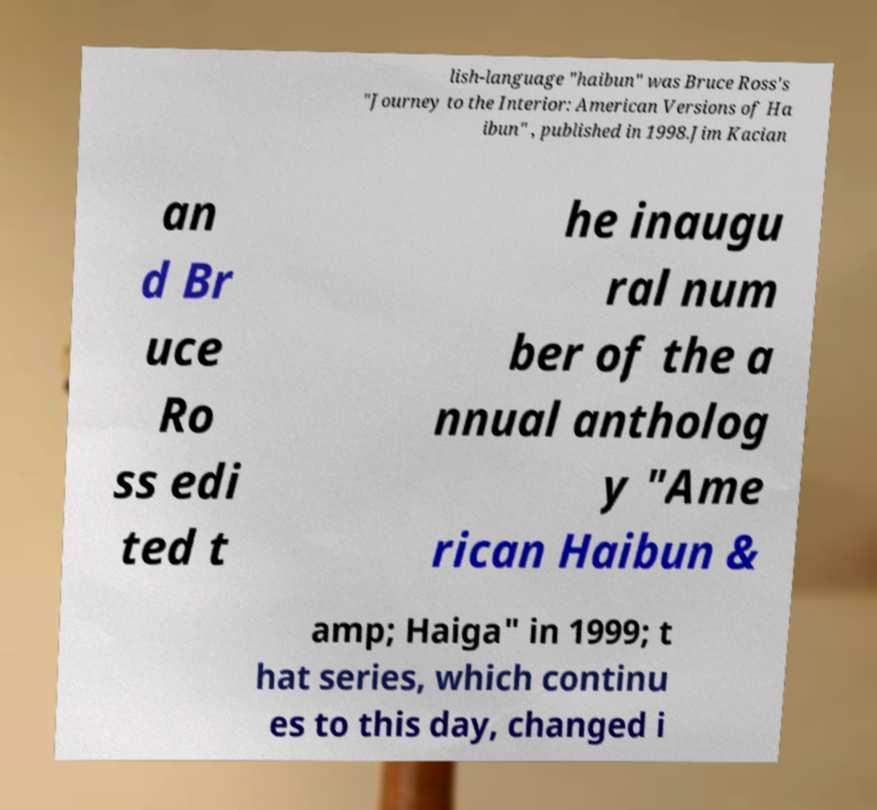Can you accurately transcribe the text from the provided image for me? lish-language "haibun" was Bruce Ross's "Journey to the Interior: American Versions of Ha ibun" , published in 1998.Jim Kacian an d Br uce Ro ss edi ted t he inaugu ral num ber of the a nnual antholog y "Ame rican Haibun & amp; Haiga" in 1999; t hat series, which continu es to this day, changed i 